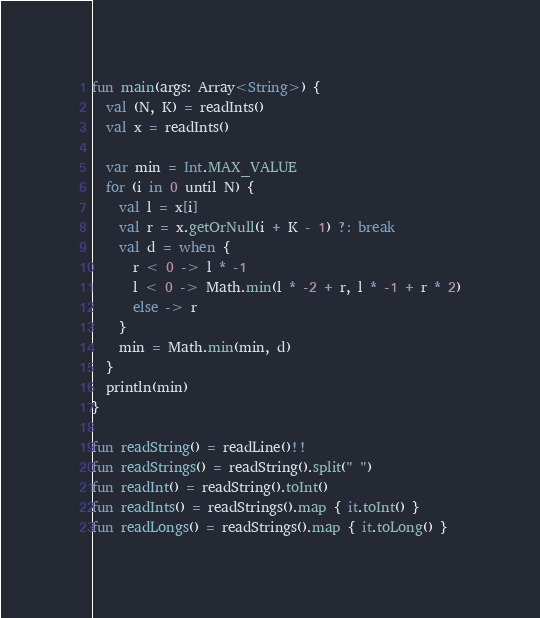Convert code to text. <code><loc_0><loc_0><loc_500><loc_500><_Kotlin_>fun main(args: Array<String>) {
  val (N, K) = readInts()
  val x = readInts()

  var min = Int.MAX_VALUE
  for (i in 0 until N) {
    val l = x[i]
    val r = x.getOrNull(i + K - 1) ?: break
    val d = when {
      r < 0 -> l * -1
      l < 0 -> Math.min(l * -2 + r, l * -1 + r * 2)
      else -> r
    }
    min = Math.min(min, d)
  }
  println(min)
}

fun readString() = readLine()!!
fun readStrings() = readString().split(" ")
fun readInt() = readString().toInt()
fun readInts() = readStrings().map { it.toInt() }
fun readLongs() = readStrings().map { it.toLong() }
</code> 